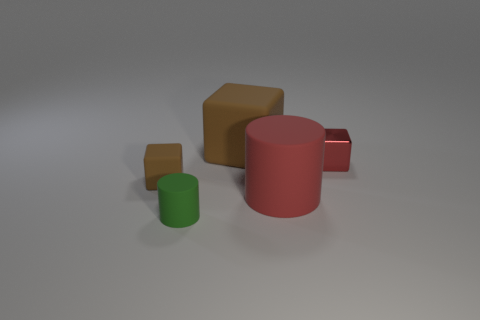There is a matte cylinder that is in front of the large red matte cylinder; what color is it? green 